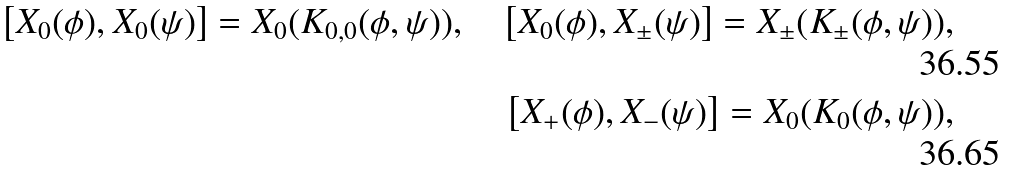Convert formula to latex. <formula><loc_0><loc_0><loc_500><loc_500>\left [ X _ { 0 } ( \phi ) , X _ { 0 } ( \psi ) \right ] = X _ { 0 } ( K _ { 0 , 0 } ( \phi , \psi ) ) , \quad \left [ X _ { 0 } ( \phi ) , X _ { \pm } ( \psi ) \right ] = X _ { \pm } ( K _ { \pm } ( \phi , \psi ) ) , \\ \left [ X _ { + } ( \phi ) , X _ { - } ( \psi ) \right ] = X _ { 0 } ( K _ { 0 } ( \phi , \psi ) ) ,</formula> 